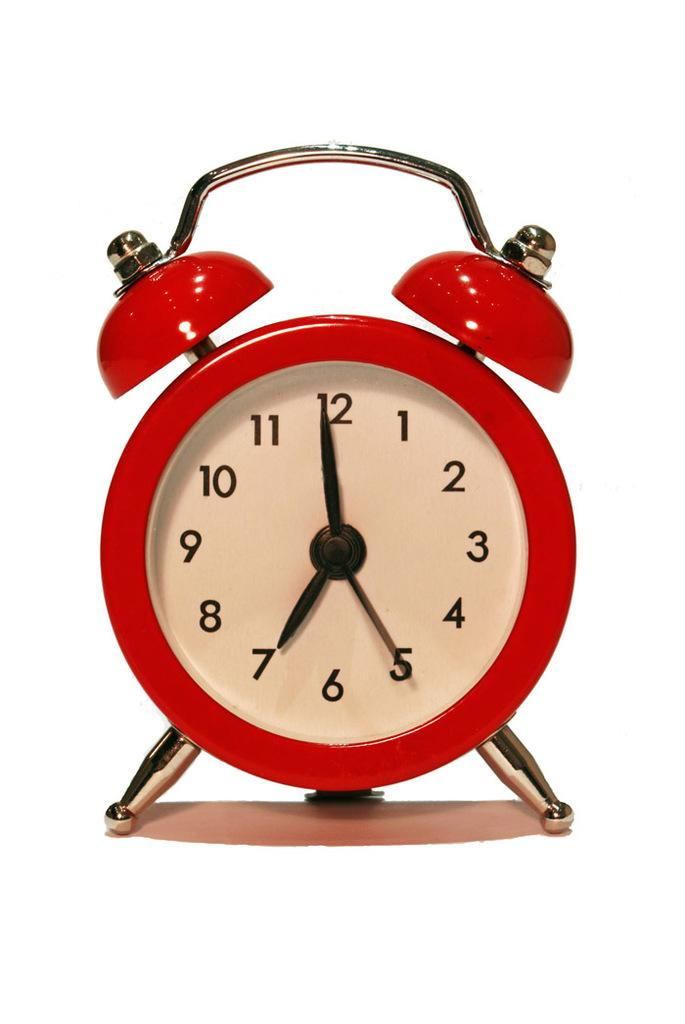<image>
Offer a succinct explanation of the picture presented. A red and white clock that signals that it is seven oclock. 